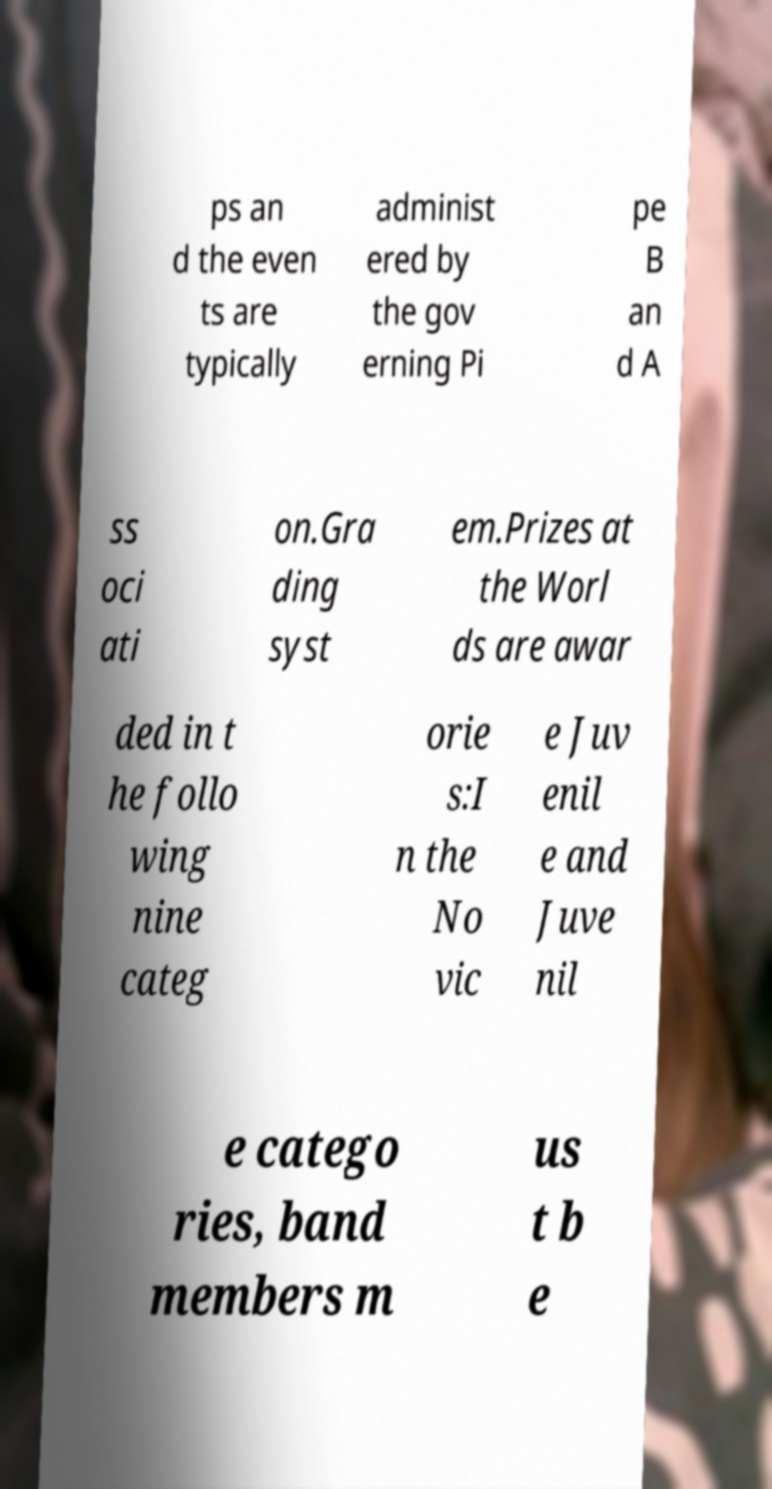Could you assist in decoding the text presented in this image and type it out clearly? ps an d the even ts are typically administ ered by the gov erning Pi pe B an d A ss oci ati on.Gra ding syst em.Prizes at the Worl ds are awar ded in t he follo wing nine categ orie s:I n the No vic e Juv enil e and Juve nil e catego ries, band members m us t b e 